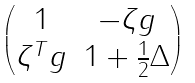Convert formula to latex. <formula><loc_0><loc_0><loc_500><loc_500>\begin{pmatrix} { 1 } & - \zeta g \\ \zeta ^ { T } g & { 1 } + \frac { 1 } { 2 } \Delta \end{pmatrix}</formula> 